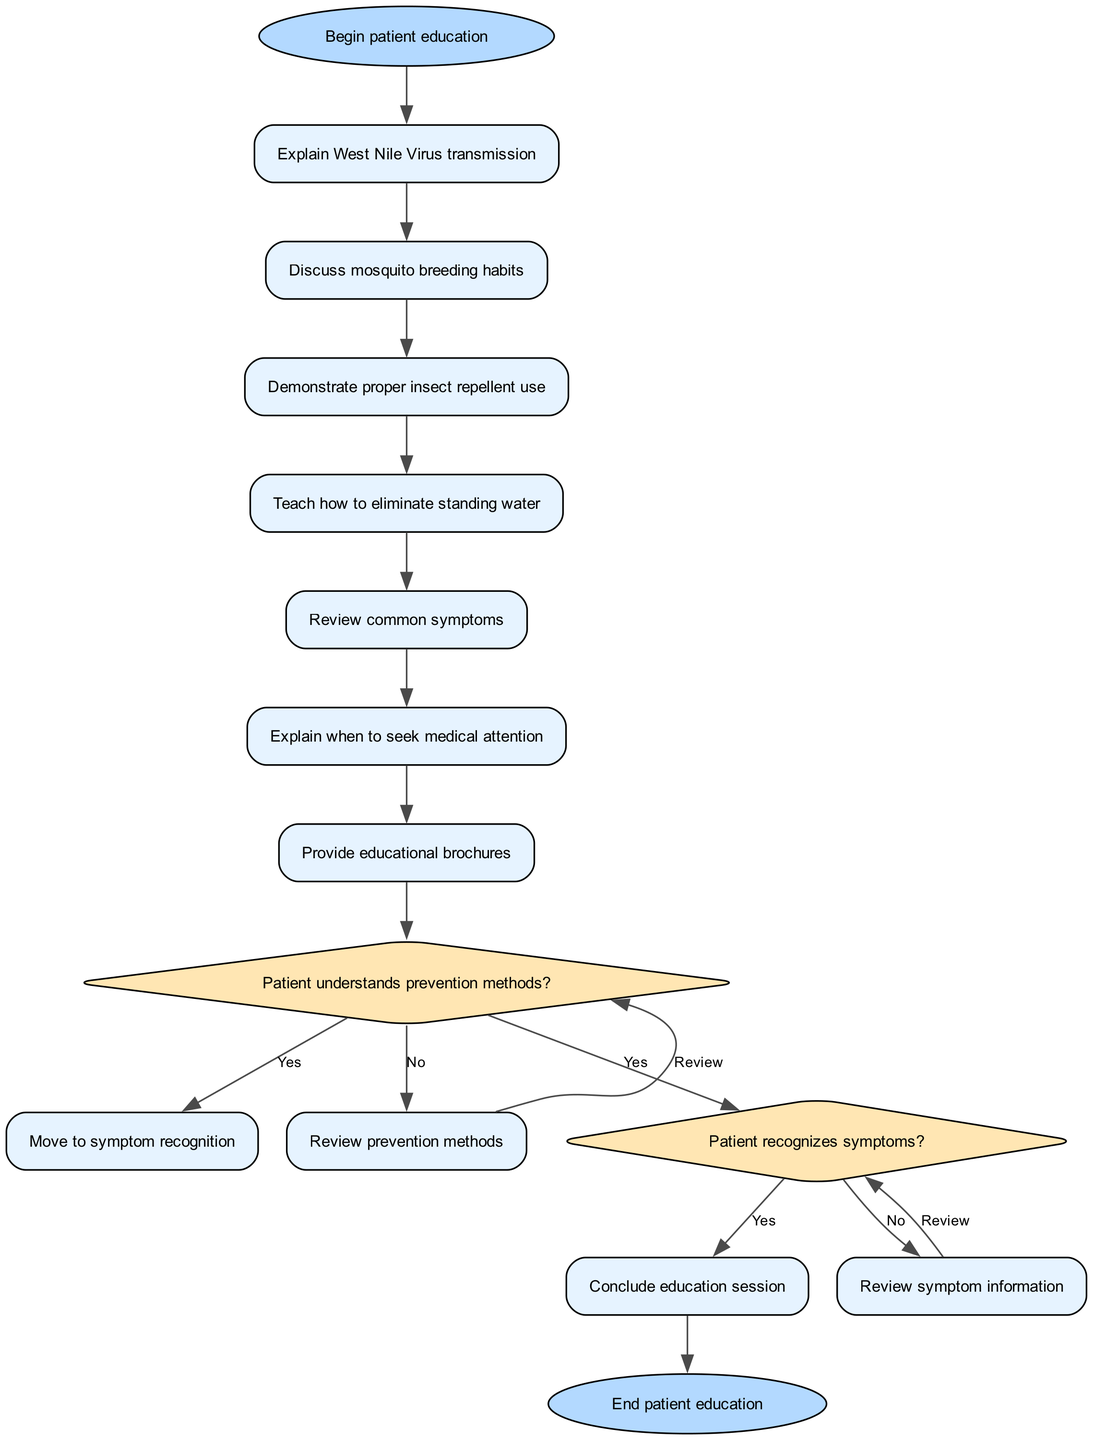What is the start node of the diagram? The start node of the diagram is identified as the first node, labeled "Begin patient education."
Answer: Begin patient education How many activities are listed in the diagram? Counting the activities provided, there are a total of 7 activities described in the diagram, from "Explain West Nile Virus transmission" to "Provide educational brochures."
Answer: 7 What is the first decision point in the diagram? The first decision point asks the question "Patient understands prevention methods?" which leads to two potential paths based on the patient's response.
Answer: Patient understands prevention methods? What happens if the patient answers 'no' to the first decision? If the patient answers 'no' to "Patient understands prevention methods?", the process loops back to "Review prevention methods", allowing for additional clarification before reassessing understanding.
Answer: Review prevention methods How many possible activities lead to the end node? The end node is reached after the second decision, specifically from the 'yes' branch of "Patient recognizes symptoms?" which concludes with the end of the education session. This indicates only one activity directly leads to the end node.
Answer: 1 What occurs after reviewing symptom information? After reviewing symptom information, there is no explicit path shown in the diagram, so it implies that the education session does not conclude at that moment but instead continues possibly leading back to the recognition of symptoms.
Answer: Not specified What color represents the decision nodes in the diagram? The decision nodes in the diagram are colored with a light yellow color, specified in the formatting as '#FFE6B3'.
Answer: #FFE6B3 Which activity is the last before the first decision? The last activity before the first decision is "Review common symptoms," which is the final step leading into the decision point regarding the patient's ability to recognize symptoms.
Answer: Review common symptoms What action follows the "Provide educational brochures" activity? Following the "Provide educational brochures," the diagram shows a transition to the first decision node, which evaluates the patient’s understanding of the prevention methods discussed.
Answer: Move to symptom recognition 